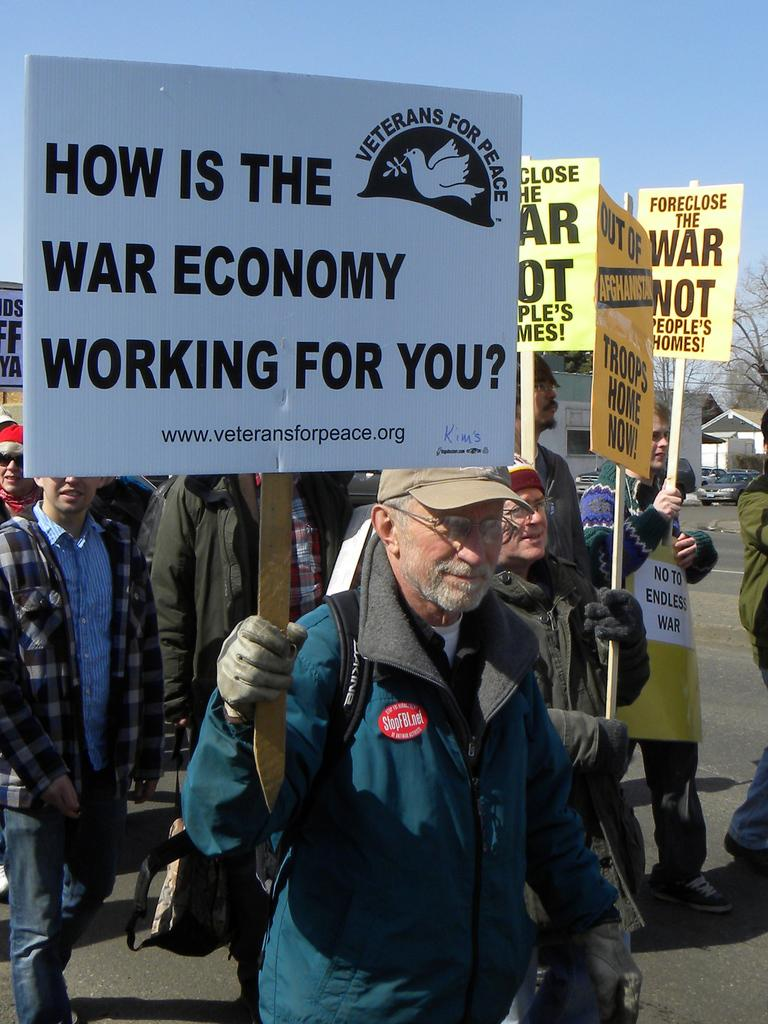What are the people in the image doing? The people in the image are walking on the road. What are the people holding while walking? The people are holding boards with text and logos. What can be seen in the background of the image? There are houses, vehicles, trees, and the sky visible in the background of the image. What type of door can be seen in the image? There is no door present in the image; it features people walking on the road and holding boards with text and logos. What idea is being expressed by the people walking on the road? The image does not provide any information about the ideas being expressed by the people walking on the road. 